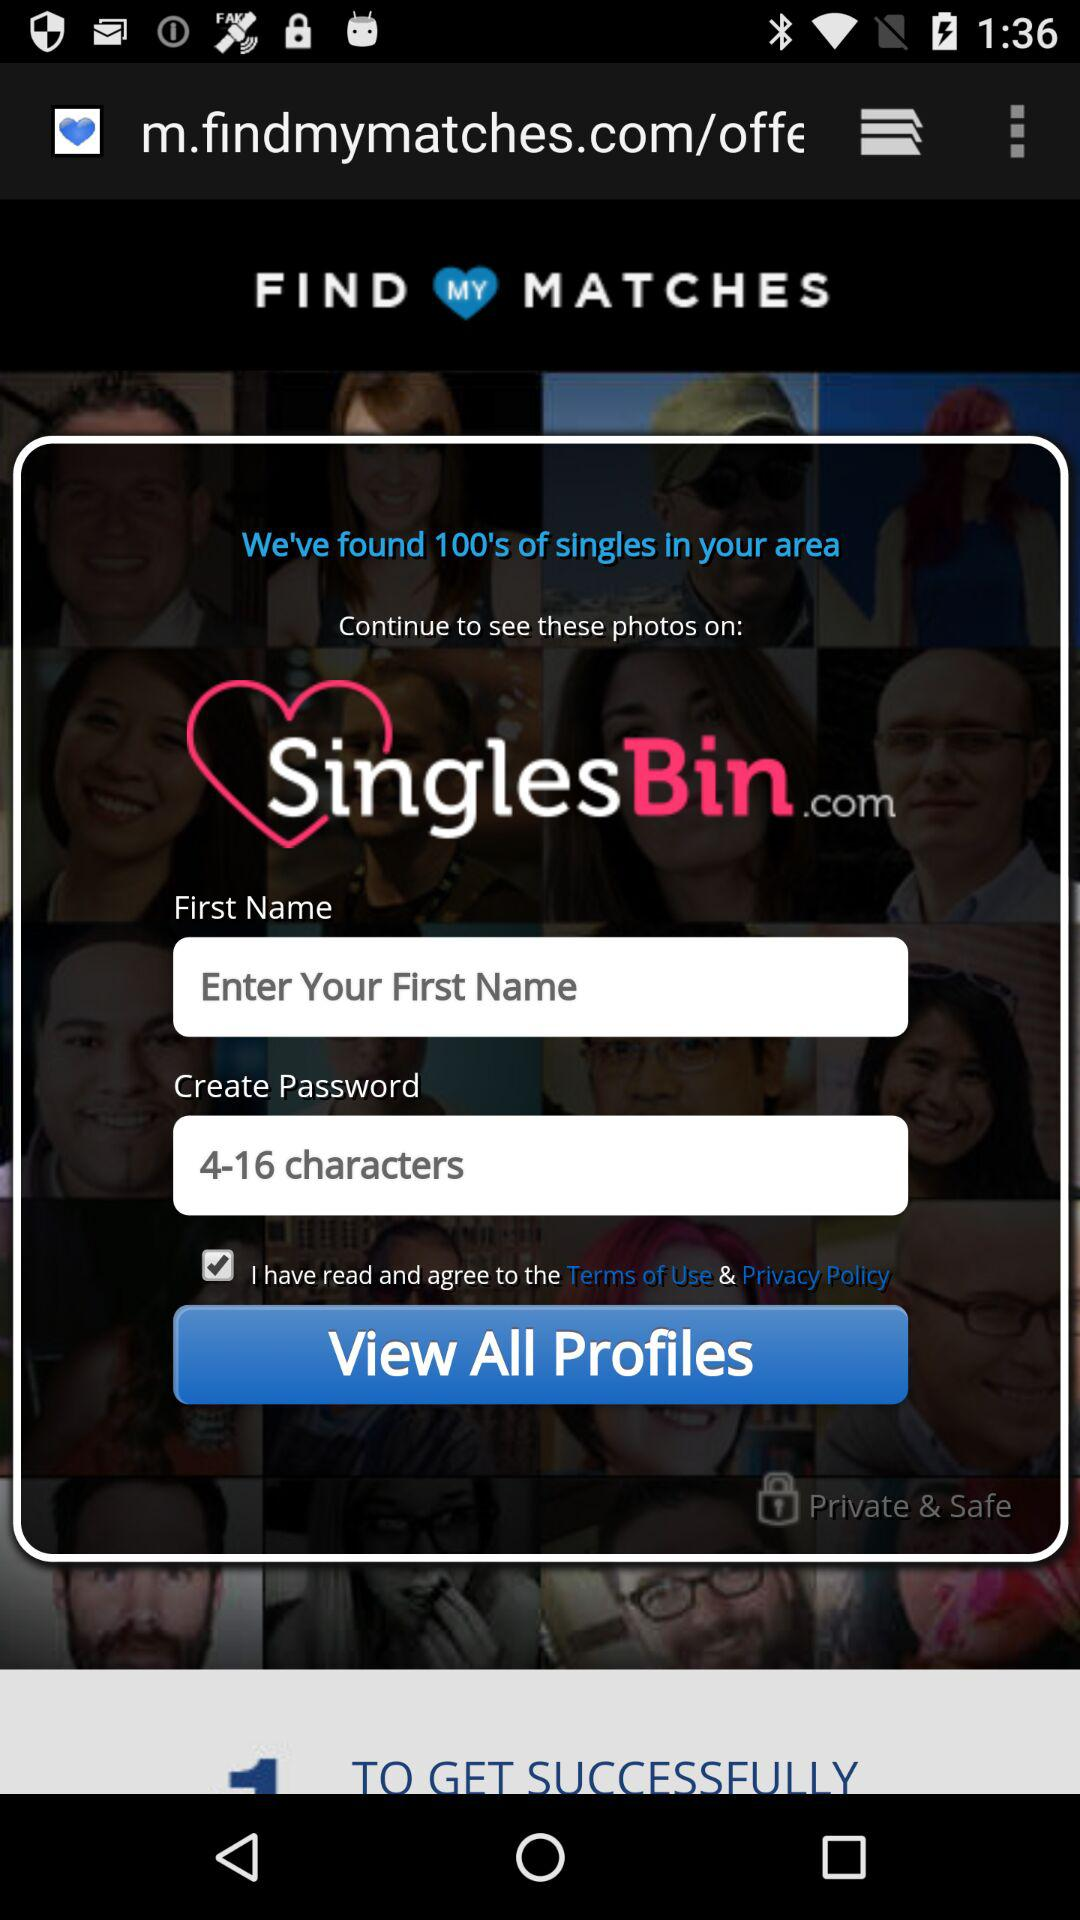What is the application name? The application name is "FIND MY MATCHES". 